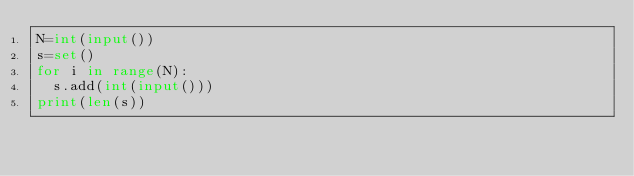Convert code to text. <code><loc_0><loc_0><loc_500><loc_500><_Python_>N=int(input())
s=set()
for i in range(N):
  s.add(int(input()))
print(len(s))</code> 